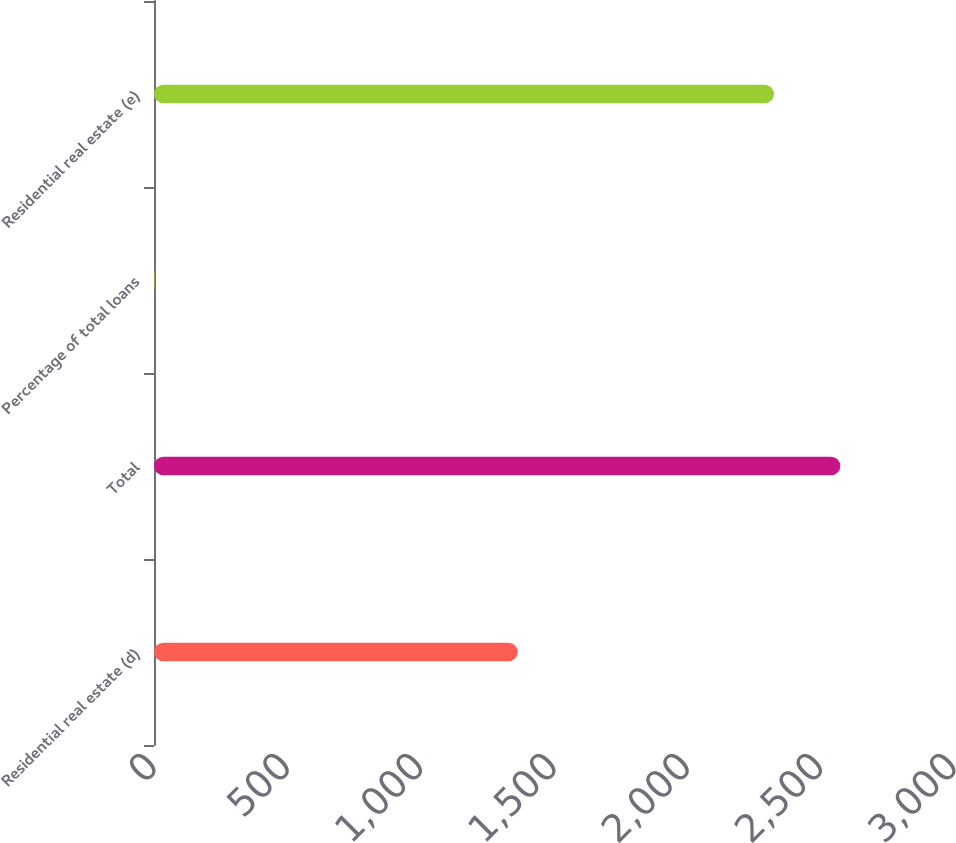Convert chart to OTSL. <chart><loc_0><loc_0><loc_500><loc_500><bar_chart><fcel>Residential real estate (d)<fcel>Total<fcel>Percentage of total loans<fcel>Residential real estate (e)<nl><fcel>1364<fcel>2573.87<fcel>1.28<fcel>2325<nl></chart> 